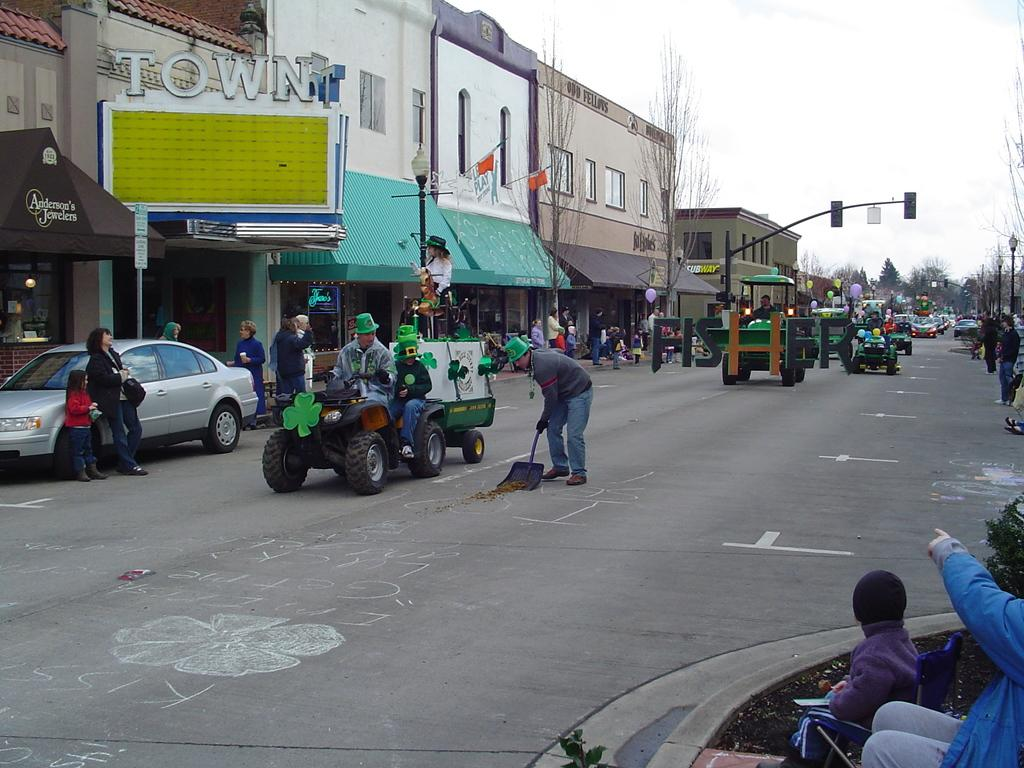What are the persons in the image doing? The persons in the image are sitting in motor vehicles on the street. What can be seen in the background of the image? Buildings, name boards, street poles, street lights, trees, and the sky are visible in the image. What is the condition of the sky in the image? The sky is visible in the image, and clouds are present in the sky. Can you see a plough being used in the image? No, there is no plough present in the image. Are there any ants visible in the image? No, there are no ants visible in the image. 